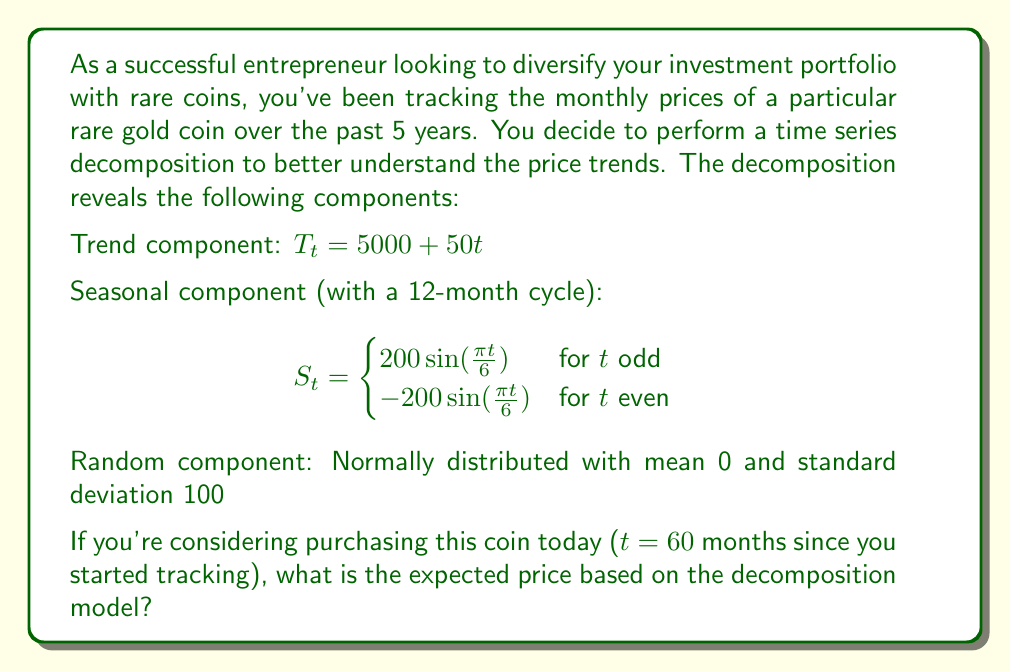Give your solution to this math problem. To find the expected price of the rare coin at t = 60 months, we need to combine the trend, seasonal, and random components of the time series decomposition. Let's go through this step-by-step:

1. Calculate the trend component at t = 60:
   $T_{60} = 5000 + 50(60) = 8000$

2. Calculate the seasonal component at t = 60:
   Since 60 is even, we use the second case of the piecewise function:
   $S_{60} = -200 \sin(\frac{\pi 60}{6}) = -200 \sin(10\pi) = 0$

3. The random component has a mean of 0, so its expected value is 0.

4. Combine all components:
   Expected Price = Trend + Seasonal + Random
   $E[Price_{60}] = T_{60} + S_{60} + E[Random]$
   $E[Price_{60}] = 8000 + 0 + 0 = 8000$

Therefore, the expected price of the rare coin at t = 60 months is $8000.
Answer: $8000 